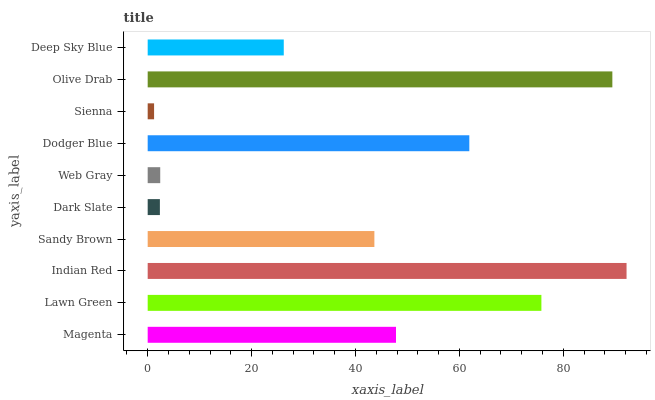Is Sienna the minimum?
Answer yes or no. Yes. Is Indian Red the maximum?
Answer yes or no. Yes. Is Lawn Green the minimum?
Answer yes or no. No. Is Lawn Green the maximum?
Answer yes or no. No. Is Lawn Green greater than Magenta?
Answer yes or no. Yes. Is Magenta less than Lawn Green?
Answer yes or no. Yes. Is Magenta greater than Lawn Green?
Answer yes or no. No. Is Lawn Green less than Magenta?
Answer yes or no. No. Is Magenta the high median?
Answer yes or no. Yes. Is Sandy Brown the low median?
Answer yes or no. Yes. Is Sienna the high median?
Answer yes or no. No. Is Deep Sky Blue the low median?
Answer yes or no. No. 